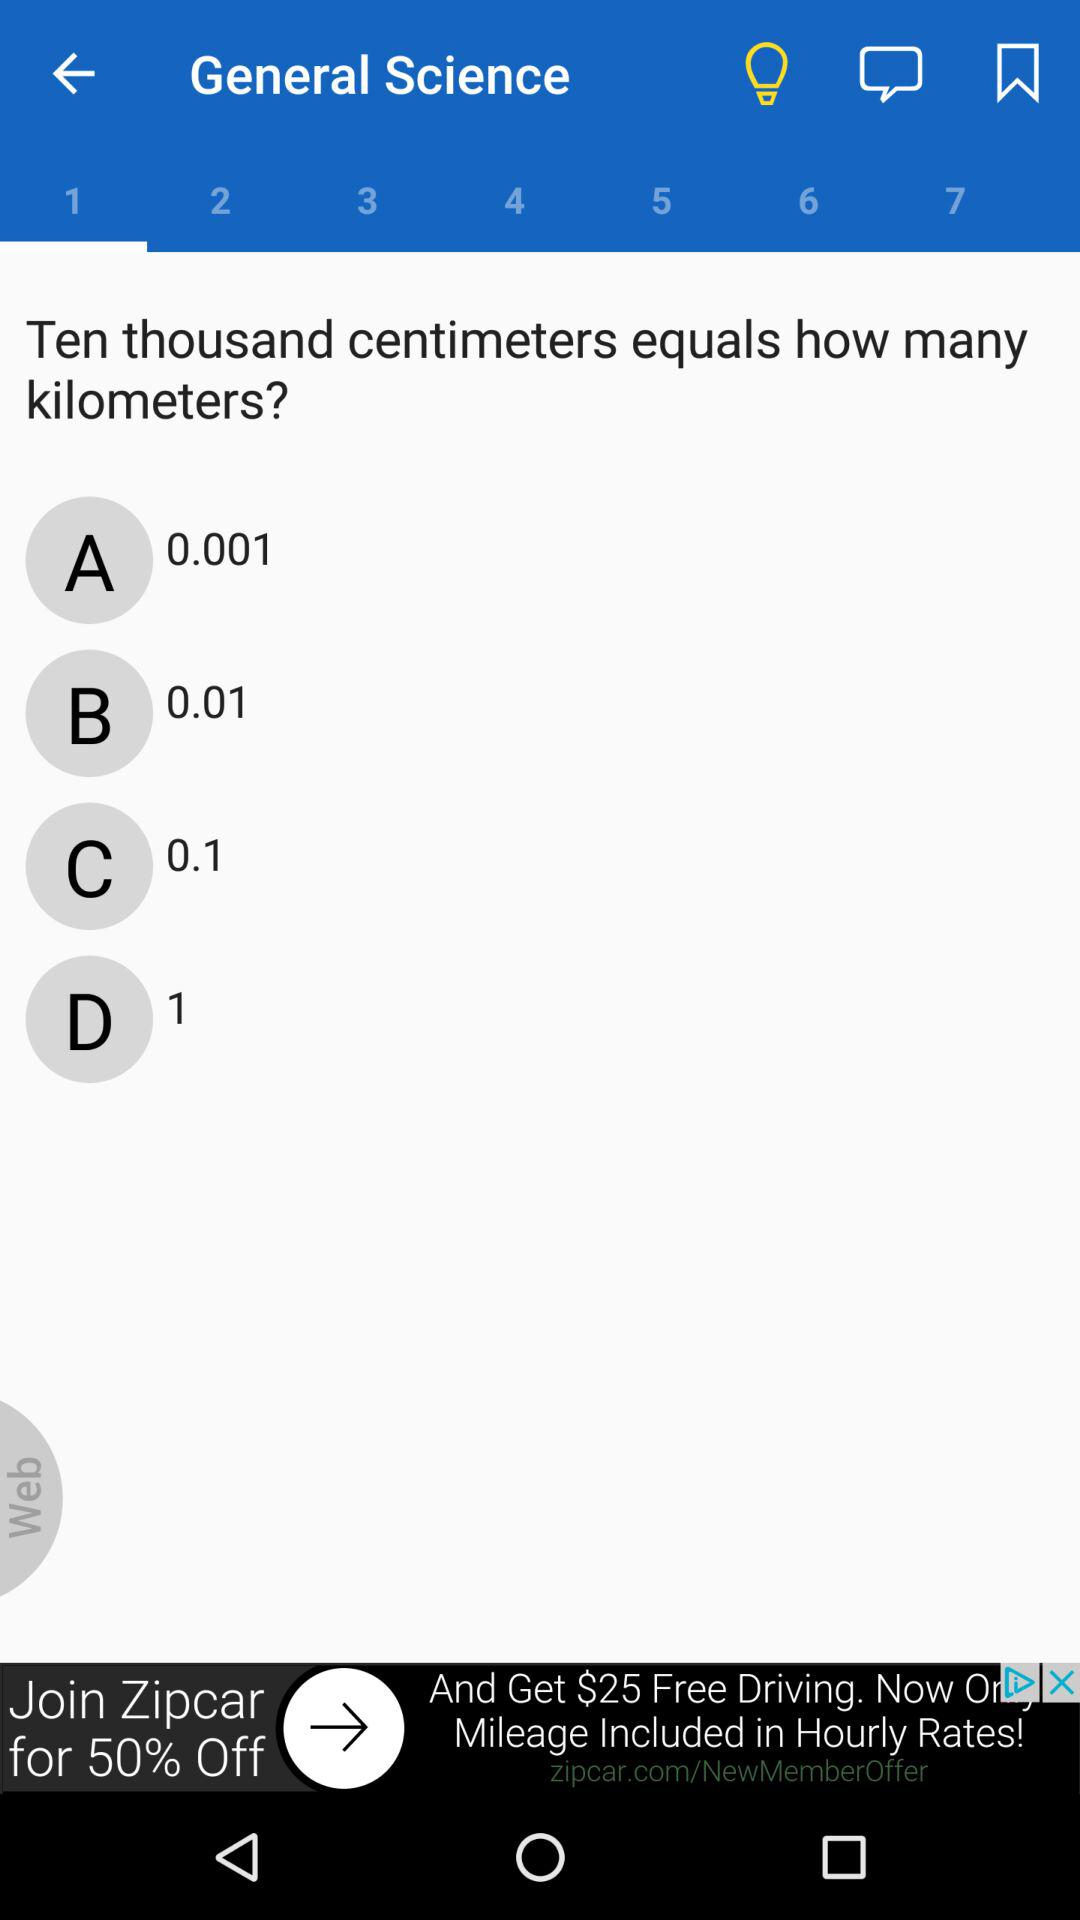How many times smaller is 0.001 kilometers than 1 kilometer?
Answer the question using a single word or phrase. 1000 